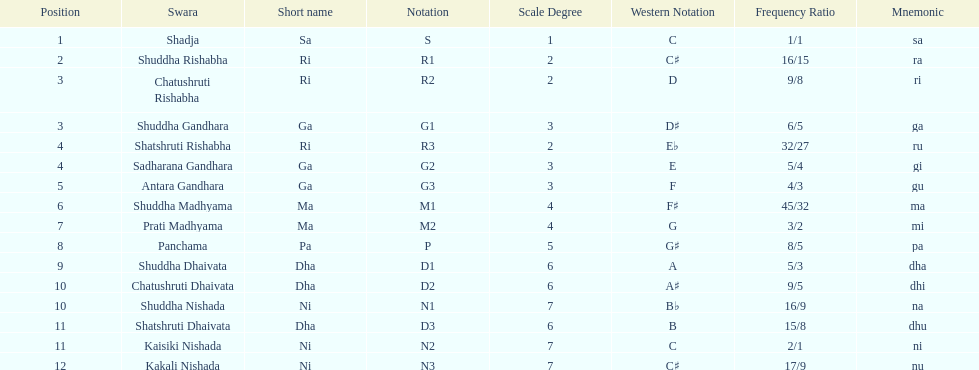Help me parse the entirety of this table. {'header': ['Position', 'Swara', 'Short name', 'Notation', 'Scale Degree', 'Western Notation', 'Frequency Ratio', 'Mnemonic'], 'rows': [['1', 'Shadja', 'Sa', 'S', '1', 'C', '1/1', 'sa'], ['2', 'Shuddha Rishabha', 'Ri', 'R1', '2', 'C♯', '16/15', 'ra'], ['3', 'Chatushruti Rishabha', 'Ri', 'R2', '2', 'D', '9/8', 'ri'], ['3', 'Shuddha Gandhara', 'Ga', 'G1', '3', 'D♯', '6/5', 'ga'], ['4', 'Shatshruti Rishabha', 'Ri', 'R3', '2', 'E♭', '32/27', 'ru'], ['4', 'Sadharana Gandhara', 'Ga', 'G2', '3', 'E', '5/4', 'gi'], ['5', 'Antara Gandhara', 'Ga', 'G3', '3', 'F', '4/3', 'gu'], ['6', 'Shuddha Madhyama', 'Ma', 'M1', '4', 'F♯', '45/32', 'ma'], ['7', 'Prati Madhyama', 'Ma', 'M2', '4', 'G', '3/2', 'mi'], ['8', 'Panchama', 'Pa', 'P', '5', 'G♯', '8/5', 'pa'], ['9', 'Shuddha Dhaivata', 'Dha', 'D1', '6', 'A', '5/3', 'dha'], ['10', 'Chatushruti Dhaivata', 'Dha', 'D2', '6', 'A♯', '9/5', 'dhi'], ['10', 'Shuddha Nishada', 'Ni', 'N1', '7', 'B♭', '16/9', 'na'], ['11', 'Shatshruti Dhaivata', 'Dha', 'D3', '6', 'B', '15/8', 'dhu'], ['11', 'Kaisiki Nishada', 'Ni', 'N2', '7', 'C', '2/1', 'ni'], ['12', 'Kakali Nishada', 'Ni', 'N3', '7', 'C♯', '17/9', 'nu']]} What swara is above shatshruti dhaivata? Shuddha Nishada. 